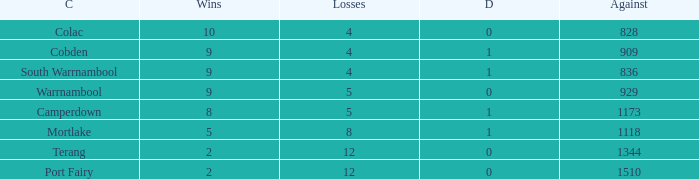What is the sum of losses for Against values over 1510? None. 